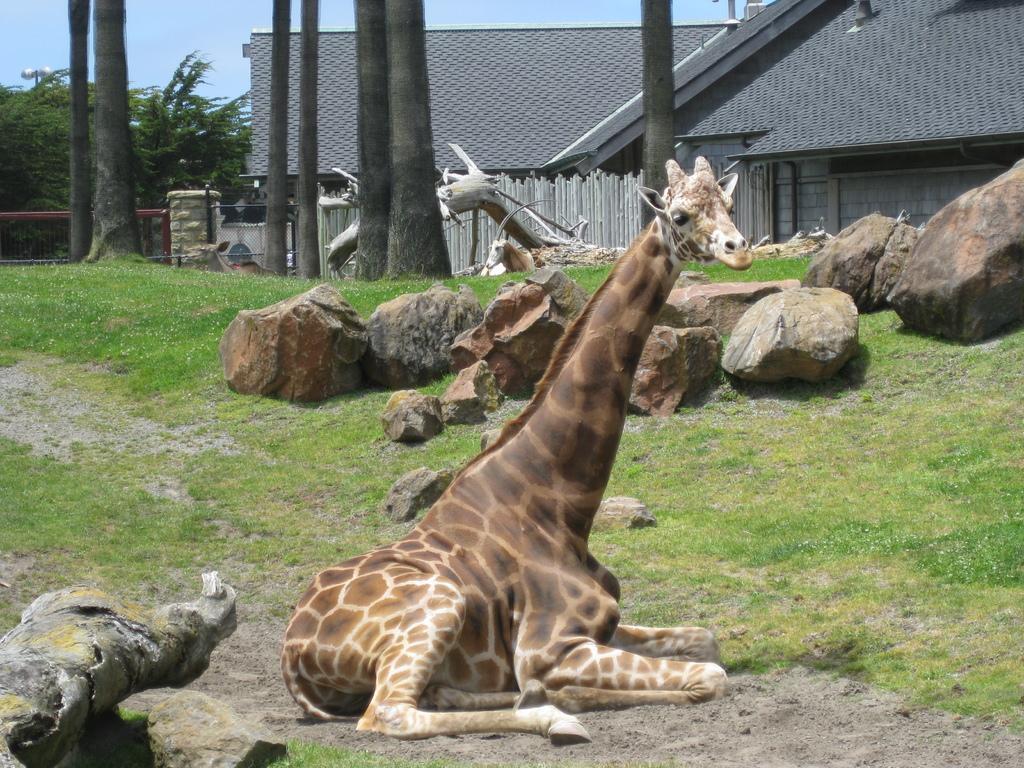Describe this image in one or two sentences. This image is taken outdoors. At the bottom of the image there is a ground with grass on it. On the left side of the image there is a bark. In the middle of the image there is a giraffe and many rocks on the ground. In the background there is a house, a fencing, a bark, railing, a few trees and a horse. At the top of the image there is a sky. 